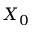Convert formula to latex. <formula><loc_0><loc_0><loc_500><loc_500>X _ { 0 }</formula> 